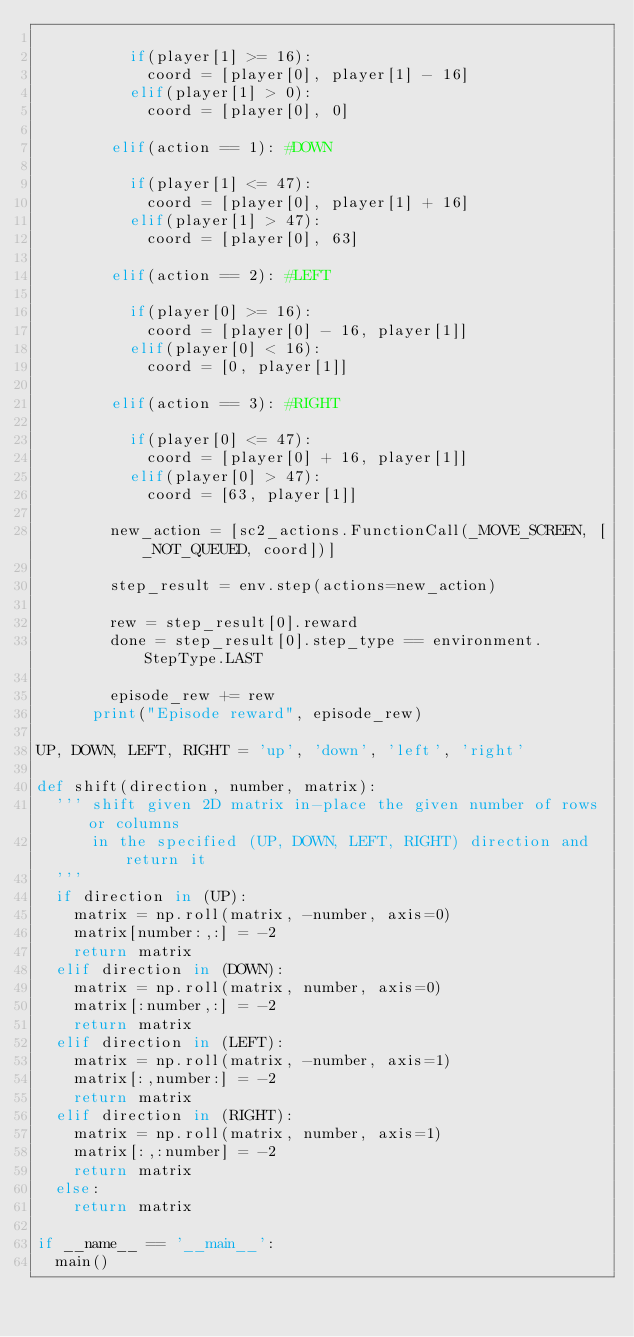Convert code to text. <code><loc_0><loc_0><loc_500><loc_500><_Python_>
          if(player[1] >= 16):
            coord = [player[0], player[1] - 16]
          elif(player[1] > 0):
            coord = [player[0], 0]

        elif(action == 1): #DOWN

          if(player[1] <= 47):
            coord = [player[0], player[1] + 16]
          elif(player[1] > 47):
            coord = [player[0], 63]

        elif(action == 2): #LEFT

          if(player[0] >= 16):
            coord = [player[0] - 16, player[1]]
          elif(player[0] < 16):
            coord = [0, player[1]]

        elif(action == 3): #RIGHT

          if(player[0] <= 47):
            coord = [player[0] + 16, player[1]]
          elif(player[0] > 47):
            coord = [63, player[1]]

        new_action = [sc2_actions.FunctionCall(_MOVE_SCREEN, [_NOT_QUEUED, coord])]

        step_result = env.step(actions=new_action)

        rew = step_result[0].reward
        done = step_result[0].step_type == environment.StepType.LAST

        episode_rew += rew
      print("Episode reward", episode_rew)

UP, DOWN, LEFT, RIGHT = 'up', 'down', 'left', 'right'

def shift(direction, number, matrix):
  ''' shift given 2D matrix in-place the given number of rows or columns
      in the specified (UP, DOWN, LEFT, RIGHT) direction and return it
  '''
  if direction in (UP):
    matrix = np.roll(matrix, -number, axis=0)
    matrix[number:,:] = -2
    return matrix
  elif direction in (DOWN):
    matrix = np.roll(matrix, number, axis=0)
    matrix[:number,:] = -2
    return matrix
  elif direction in (LEFT):
    matrix = np.roll(matrix, -number, axis=1)
    matrix[:,number:] = -2
    return matrix
  elif direction in (RIGHT):
    matrix = np.roll(matrix, number, axis=1)
    matrix[:,:number] = -2
    return matrix
  else:
    return matrix

if __name__ == '__main__':
  main()
</code> 